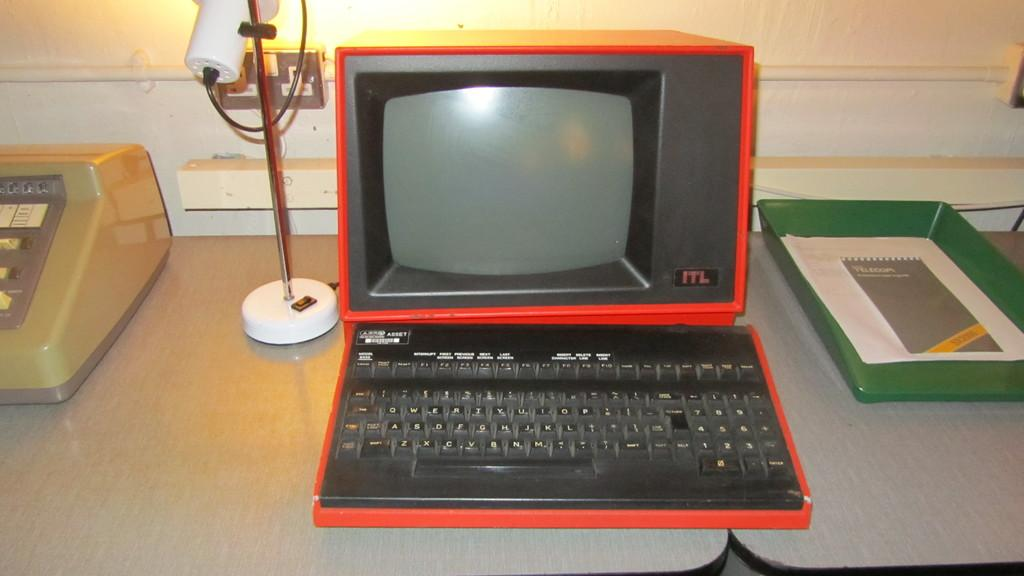<image>
Render a clear and concise summary of the photo. The old black and red computer is made by ITL. 